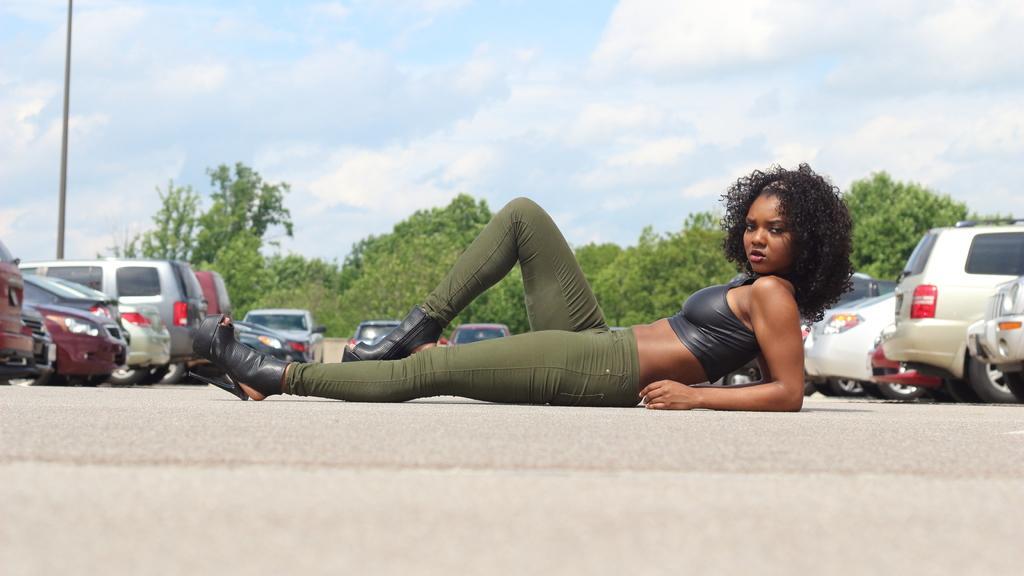Could you give a brief overview of what you see in this image? In this image there is a lady lay on the road, around her there are vehicles parked. In the background there are trees, pole and the sky. 